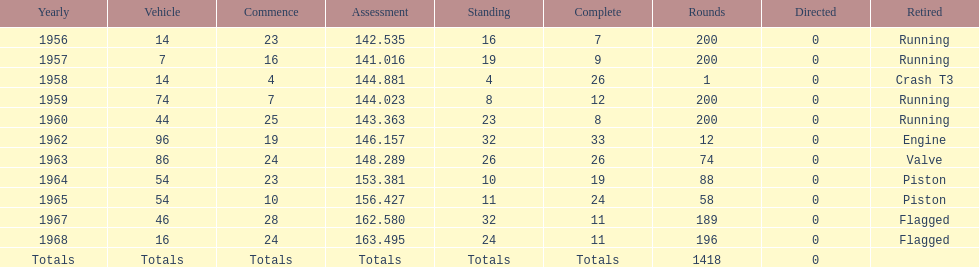How long did bob veith have the number 54 car at the indy 500? 2 years. 